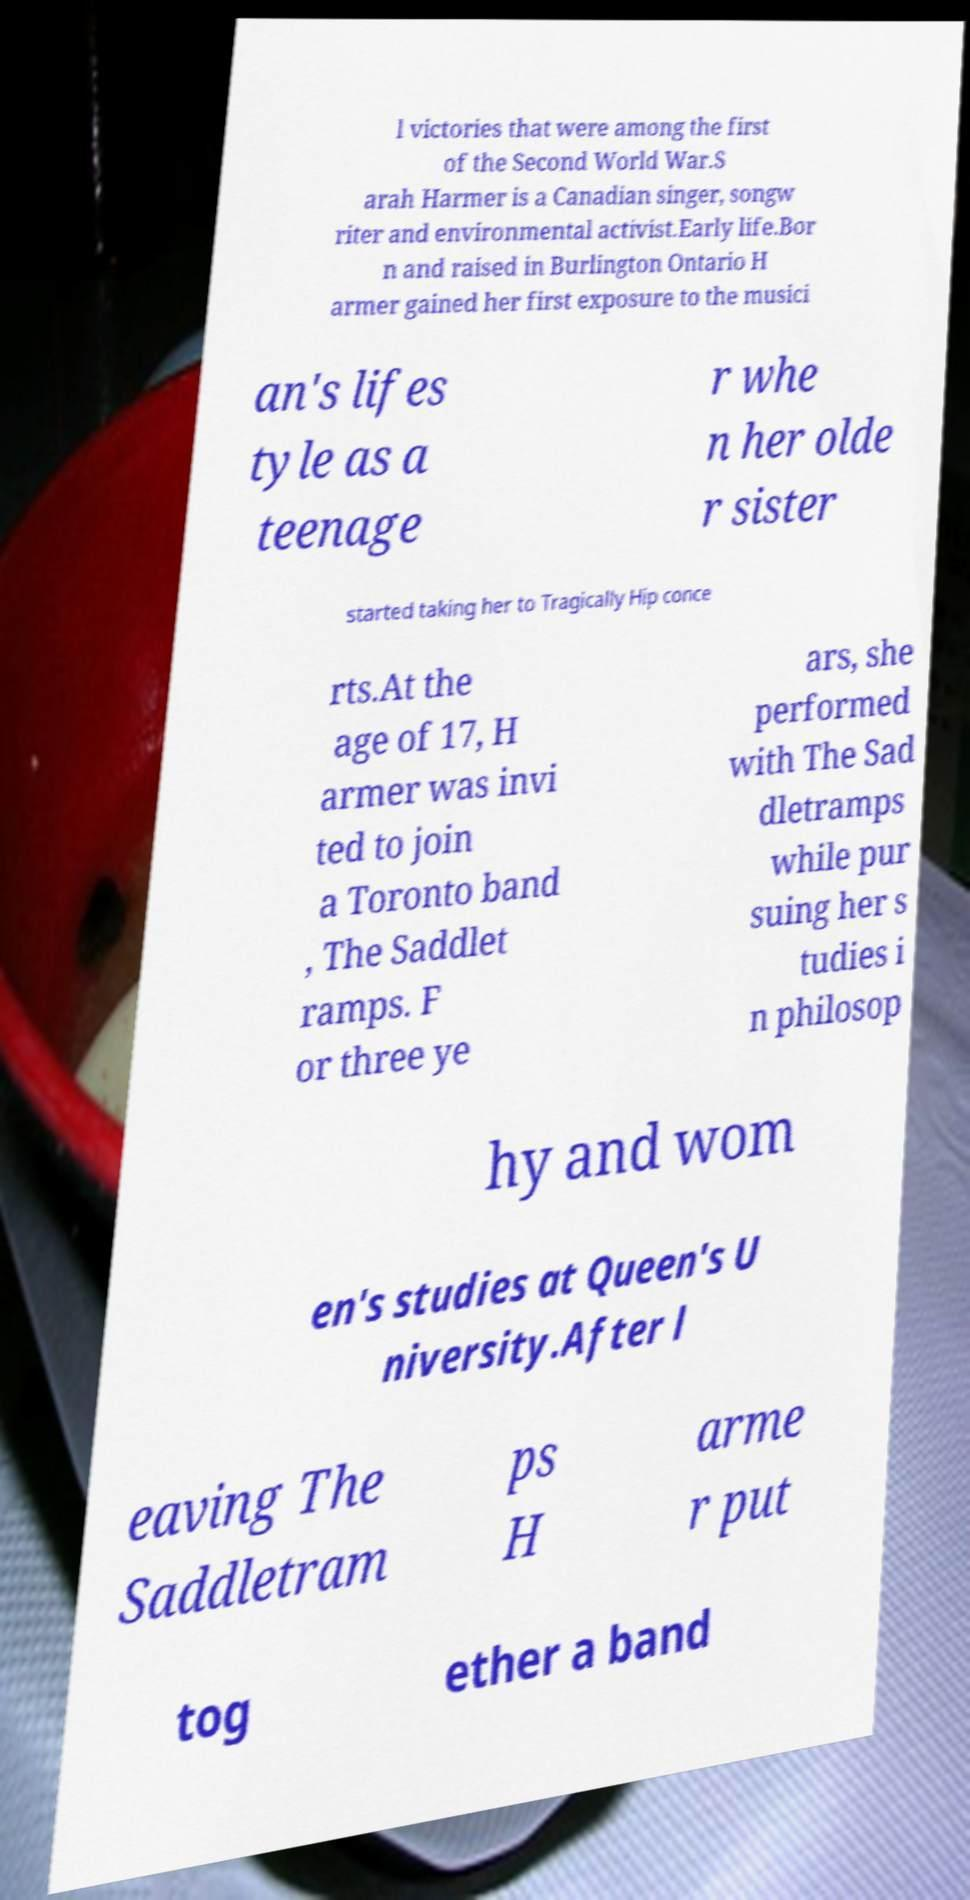I need the written content from this picture converted into text. Can you do that? l victories that were among the first of the Second World War.S arah Harmer is a Canadian singer, songw riter and environmental activist.Early life.Bor n and raised in Burlington Ontario H armer gained her first exposure to the musici an's lifes tyle as a teenage r whe n her olde r sister started taking her to Tragically Hip conce rts.At the age of 17, H armer was invi ted to join a Toronto band , The Saddlet ramps. F or three ye ars, she performed with The Sad dletramps while pur suing her s tudies i n philosop hy and wom en's studies at Queen's U niversity.After l eaving The Saddletram ps H arme r put tog ether a band 